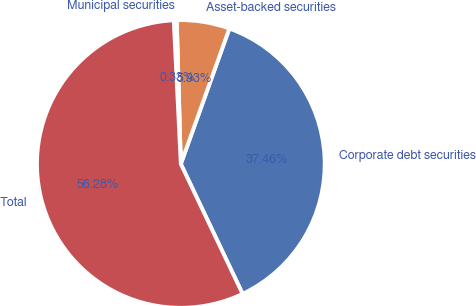Convert chart to OTSL. <chart><loc_0><loc_0><loc_500><loc_500><pie_chart><fcel>Corporate debt securities<fcel>Asset-backed securities<fcel>Municipal securities<fcel>Total<nl><fcel>37.46%<fcel>5.93%<fcel>0.33%<fcel>56.28%<nl></chart> 